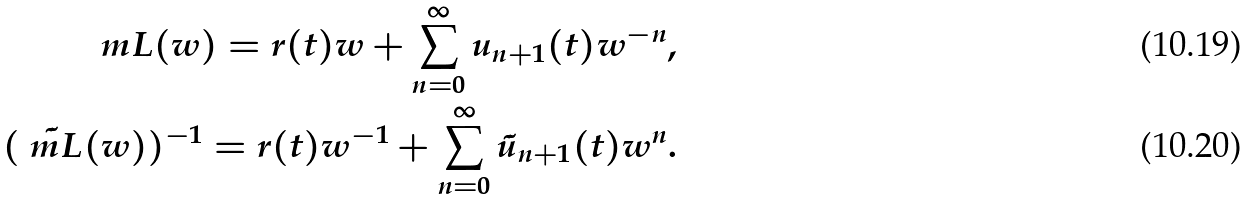<formula> <loc_0><loc_0><loc_500><loc_500>\ m L ( w ) = r ( t ) w + \sum _ { n = 0 } ^ { \infty } u _ { n + 1 } ( t ) w ^ { - n } , \\ ( \tilde { \ m L } ( w ) ) ^ { - 1 } = r ( t ) w ^ { - 1 } + \sum _ { n = 0 } ^ { \infty } \tilde { u } _ { n + 1 } ( t ) w ^ { n } .</formula> 